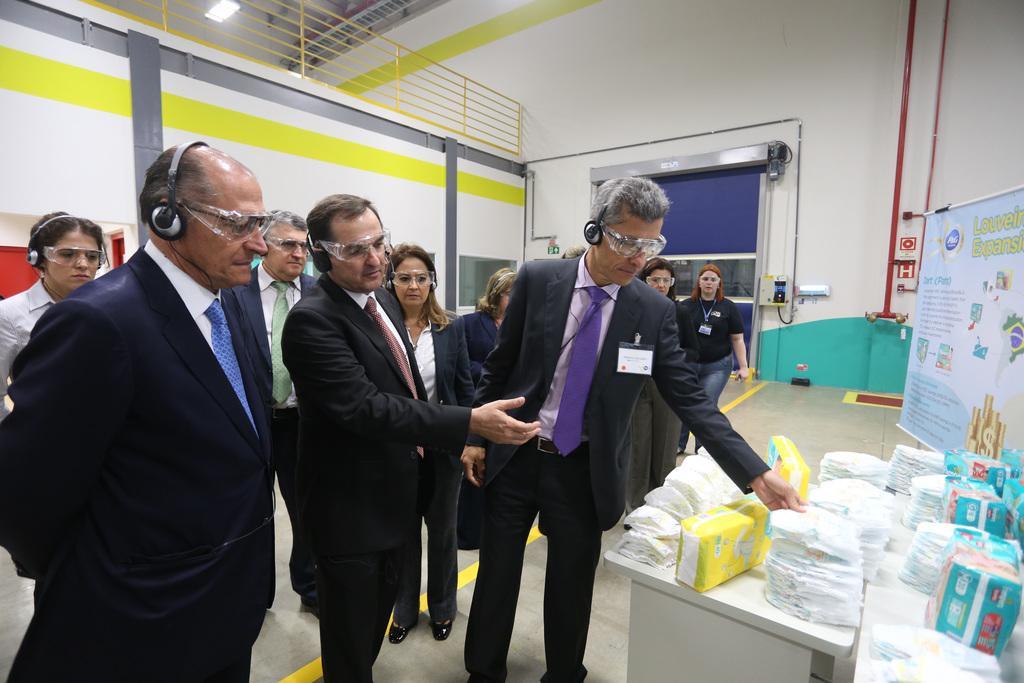How would you summarize this image in a sentence or two? 3 Men are standing all of them wore black color coats. In the right side there are things on this table. In the left side at the top it's a light. 